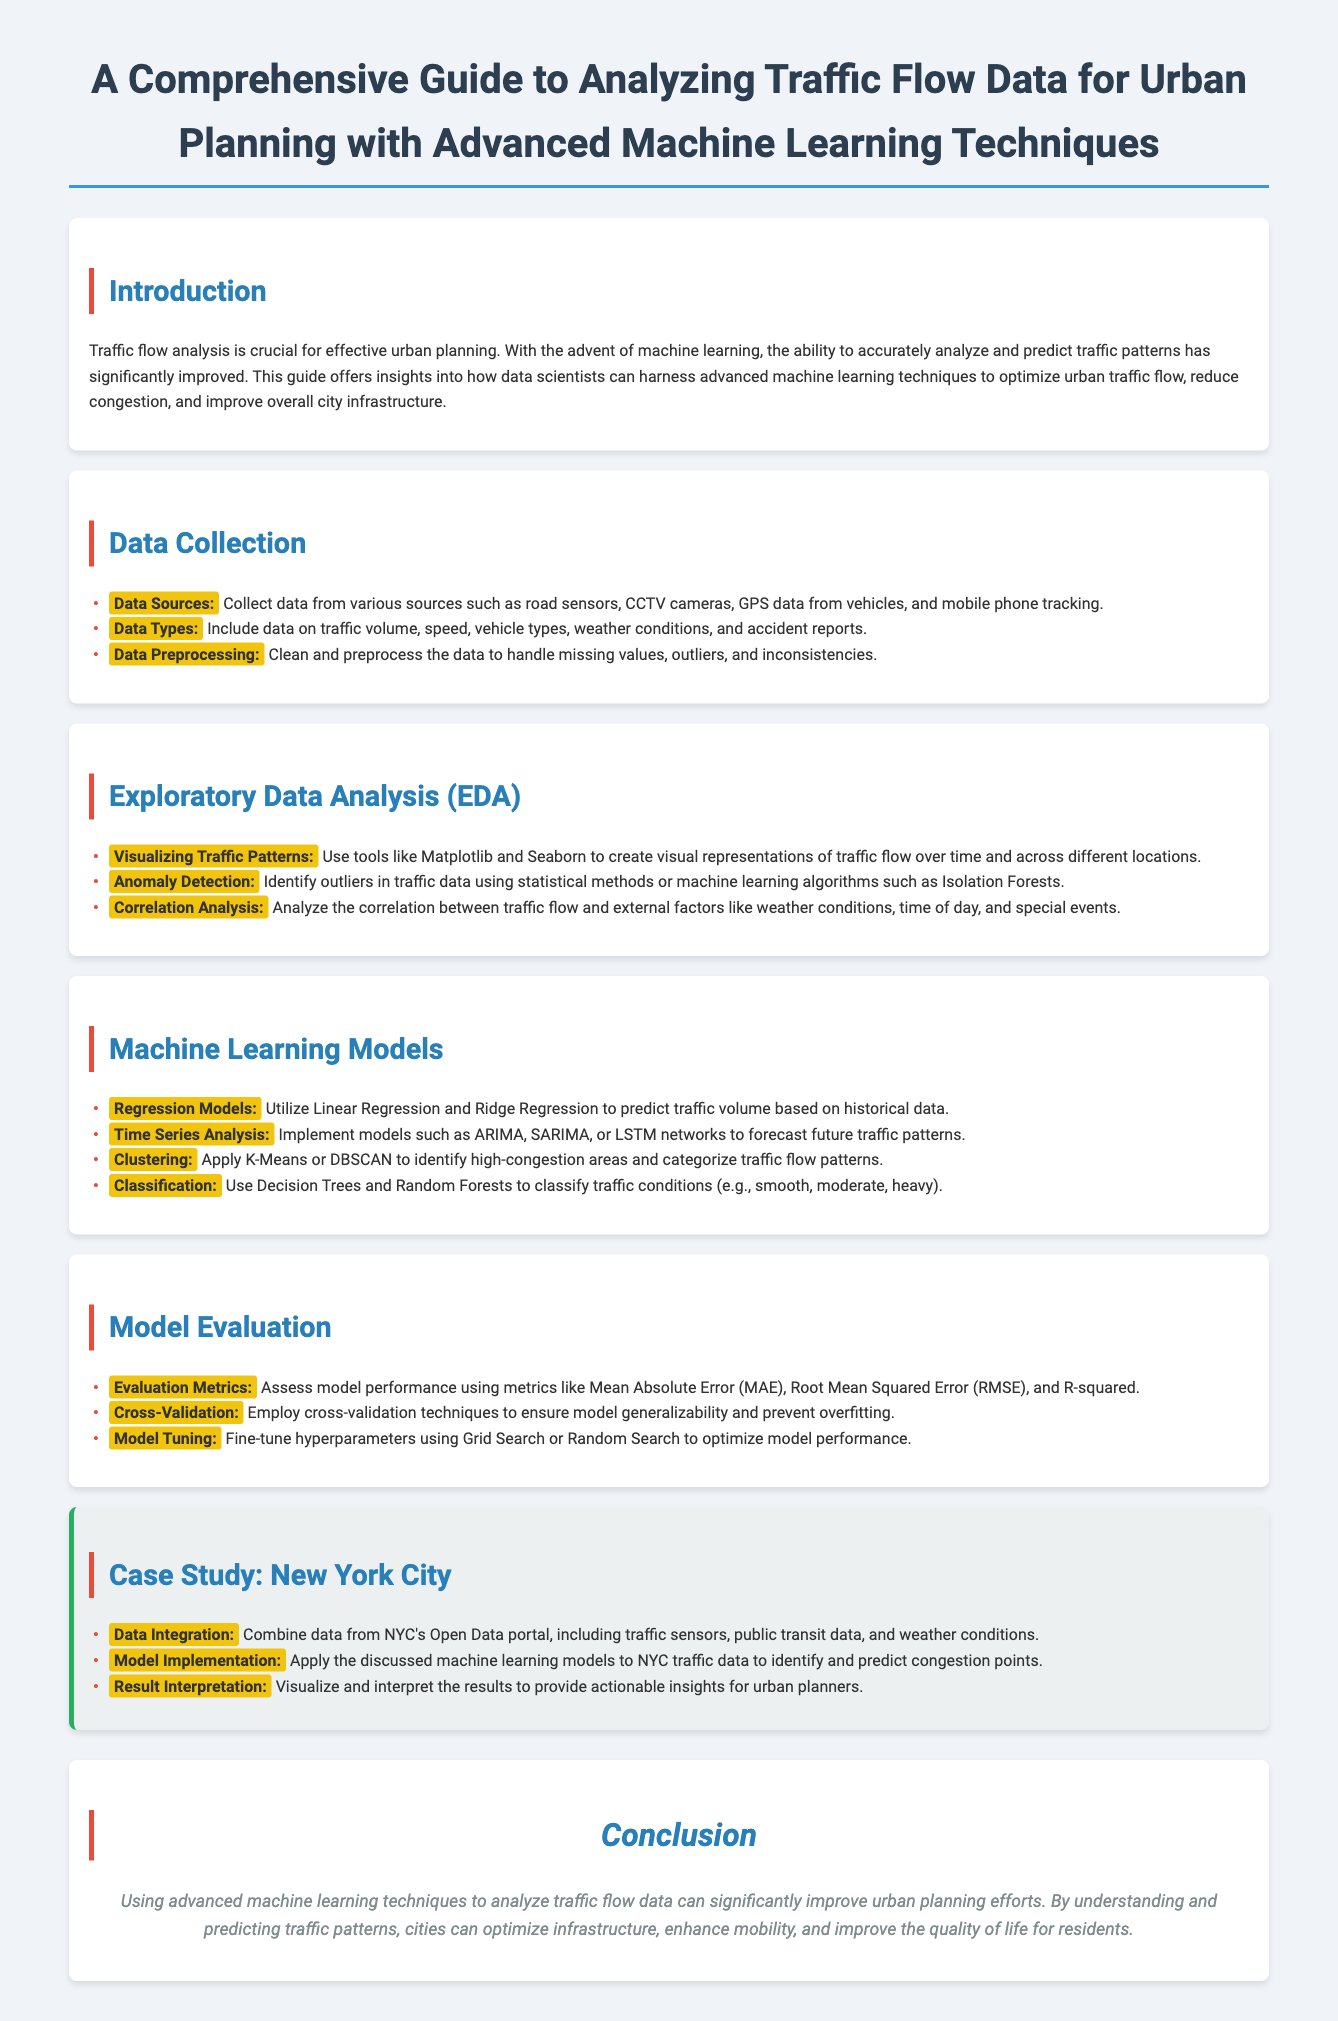what is the title of the document? The title is clearly stated at the beginning of the document.
Answer: A Comprehensive Guide to Analyzing Traffic Flow Data for Urban Planning with Advanced Machine Learning Techniques what are the data sources mentioned in the document? The document lists the sources of data collection for traffic flow analysis.
Answer: road sensors, CCTV cameras, GPS data from vehicles, and mobile phone tracking which machine learning models are suggested for traffic flow analysis? The document details various machine learning models applicable for traffic analysis.
Answer: Regression Models, Time Series Analysis, Clustering, Classification what evaluation metrics are suggested for model performance assessment? The document provides specific metrics for evaluating machine learning model performance.
Answer: Mean Absolute Error, Root Mean Squared Error, R-squared in which city is the case study focused? The document specifies the location of the case study included in the guide.
Answer: New York City what is the purpose of data preprocessing? The document explains the importance of data preprocessing in the analysis workflow.
Answer: Handle missing values, outliers, and inconsistencies which library is mentioned for visualizing traffic patterns? The document suggests tools for creating visual representations of traffic data.
Answer: Matplotlib and Seaborn what is one machine learning technique for identifying outliers in traffic data? The document mentions a specific technique for anomaly detection in traffic datasets.
Answer: Isolation Forests 